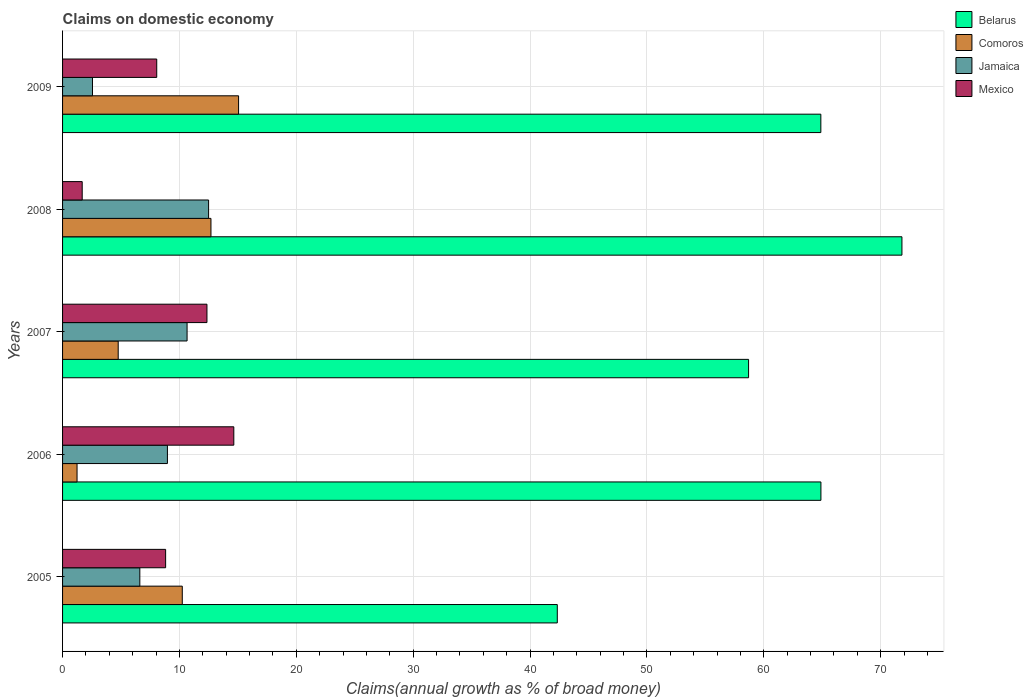How many different coloured bars are there?
Provide a short and direct response. 4. How many groups of bars are there?
Provide a short and direct response. 5. What is the label of the 2nd group of bars from the top?
Offer a terse response. 2008. What is the percentage of broad money claimed on domestic economy in Mexico in 2005?
Ensure brevity in your answer.  8.82. Across all years, what is the maximum percentage of broad money claimed on domestic economy in Comoros?
Provide a succinct answer. 15.06. Across all years, what is the minimum percentage of broad money claimed on domestic economy in Mexico?
Offer a terse response. 1.68. What is the total percentage of broad money claimed on domestic economy in Mexico in the graph?
Offer a very short reply. 45.56. What is the difference between the percentage of broad money claimed on domestic economy in Jamaica in 2008 and that in 2009?
Make the answer very short. 9.93. What is the difference between the percentage of broad money claimed on domestic economy in Belarus in 2005 and the percentage of broad money claimed on domestic economy in Jamaica in 2009?
Offer a very short reply. 39.77. What is the average percentage of broad money claimed on domestic economy in Belarus per year?
Offer a very short reply. 60.52. In the year 2008, what is the difference between the percentage of broad money claimed on domestic economy in Jamaica and percentage of broad money claimed on domestic economy in Comoros?
Make the answer very short. -0.2. What is the ratio of the percentage of broad money claimed on domestic economy in Jamaica in 2006 to that in 2008?
Provide a short and direct response. 0.72. What is the difference between the highest and the second highest percentage of broad money claimed on domestic economy in Mexico?
Keep it short and to the point. 2.3. What is the difference between the highest and the lowest percentage of broad money claimed on domestic economy in Comoros?
Ensure brevity in your answer.  13.82. What does the 2nd bar from the top in 2008 represents?
Your answer should be compact. Jamaica. Is it the case that in every year, the sum of the percentage of broad money claimed on domestic economy in Mexico and percentage of broad money claimed on domestic economy in Comoros is greater than the percentage of broad money claimed on domestic economy in Belarus?
Your response must be concise. No. How many bars are there?
Offer a terse response. 20. What is the difference between two consecutive major ticks on the X-axis?
Offer a very short reply. 10. Are the values on the major ticks of X-axis written in scientific E-notation?
Your response must be concise. No. Does the graph contain grids?
Your answer should be compact. Yes. What is the title of the graph?
Make the answer very short. Claims on domestic economy. Does "Bahrain" appear as one of the legend labels in the graph?
Ensure brevity in your answer.  No. What is the label or title of the X-axis?
Make the answer very short. Claims(annual growth as % of broad money). What is the Claims(annual growth as % of broad money) of Belarus in 2005?
Offer a very short reply. 42.33. What is the Claims(annual growth as % of broad money) of Comoros in 2005?
Give a very brief answer. 10.24. What is the Claims(annual growth as % of broad money) in Jamaica in 2005?
Make the answer very short. 6.61. What is the Claims(annual growth as % of broad money) in Mexico in 2005?
Your response must be concise. 8.82. What is the Claims(annual growth as % of broad money) of Belarus in 2006?
Offer a terse response. 64.89. What is the Claims(annual growth as % of broad money) in Comoros in 2006?
Offer a terse response. 1.24. What is the Claims(annual growth as % of broad money) of Jamaica in 2006?
Provide a short and direct response. 8.97. What is the Claims(annual growth as % of broad money) in Mexico in 2006?
Ensure brevity in your answer.  14.65. What is the Claims(annual growth as % of broad money) in Belarus in 2007?
Ensure brevity in your answer.  58.7. What is the Claims(annual growth as % of broad money) in Comoros in 2007?
Make the answer very short. 4.76. What is the Claims(annual growth as % of broad money) of Jamaica in 2007?
Ensure brevity in your answer.  10.65. What is the Claims(annual growth as % of broad money) in Mexico in 2007?
Your answer should be compact. 12.35. What is the Claims(annual growth as % of broad money) in Belarus in 2008?
Your answer should be compact. 71.82. What is the Claims(annual growth as % of broad money) of Comoros in 2008?
Your response must be concise. 12.7. What is the Claims(annual growth as % of broad money) of Jamaica in 2008?
Your response must be concise. 12.49. What is the Claims(annual growth as % of broad money) of Mexico in 2008?
Give a very brief answer. 1.68. What is the Claims(annual growth as % of broad money) in Belarus in 2009?
Your answer should be very brief. 64.88. What is the Claims(annual growth as % of broad money) of Comoros in 2009?
Ensure brevity in your answer.  15.06. What is the Claims(annual growth as % of broad money) of Jamaica in 2009?
Give a very brief answer. 2.56. What is the Claims(annual growth as % of broad money) in Mexico in 2009?
Your answer should be very brief. 8.06. Across all years, what is the maximum Claims(annual growth as % of broad money) in Belarus?
Keep it short and to the point. 71.82. Across all years, what is the maximum Claims(annual growth as % of broad money) in Comoros?
Your response must be concise. 15.06. Across all years, what is the maximum Claims(annual growth as % of broad money) in Jamaica?
Your response must be concise. 12.49. Across all years, what is the maximum Claims(annual growth as % of broad money) in Mexico?
Keep it short and to the point. 14.65. Across all years, what is the minimum Claims(annual growth as % of broad money) of Belarus?
Make the answer very short. 42.33. Across all years, what is the minimum Claims(annual growth as % of broad money) of Comoros?
Provide a short and direct response. 1.24. Across all years, what is the minimum Claims(annual growth as % of broad money) in Jamaica?
Make the answer very short. 2.56. Across all years, what is the minimum Claims(annual growth as % of broad money) of Mexico?
Your answer should be very brief. 1.68. What is the total Claims(annual growth as % of broad money) in Belarus in the graph?
Your answer should be compact. 302.62. What is the total Claims(annual growth as % of broad money) of Comoros in the graph?
Give a very brief answer. 44. What is the total Claims(annual growth as % of broad money) in Jamaica in the graph?
Ensure brevity in your answer.  41.29. What is the total Claims(annual growth as % of broad money) in Mexico in the graph?
Offer a very short reply. 45.56. What is the difference between the Claims(annual growth as % of broad money) of Belarus in 2005 and that in 2006?
Provide a short and direct response. -22.56. What is the difference between the Claims(annual growth as % of broad money) in Comoros in 2005 and that in 2006?
Ensure brevity in your answer.  9. What is the difference between the Claims(annual growth as % of broad money) of Jamaica in 2005 and that in 2006?
Offer a very short reply. -2.36. What is the difference between the Claims(annual growth as % of broad money) of Mexico in 2005 and that in 2006?
Provide a succinct answer. -5.83. What is the difference between the Claims(annual growth as % of broad money) in Belarus in 2005 and that in 2007?
Your answer should be very brief. -16.37. What is the difference between the Claims(annual growth as % of broad money) in Comoros in 2005 and that in 2007?
Your answer should be very brief. 5.48. What is the difference between the Claims(annual growth as % of broad money) in Jamaica in 2005 and that in 2007?
Provide a succinct answer. -4.04. What is the difference between the Claims(annual growth as % of broad money) in Mexico in 2005 and that in 2007?
Offer a terse response. -3.54. What is the difference between the Claims(annual growth as % of broad money) of Belarus in 2005 and that in 2008?
Keep it short and to the point. -29.49. What is the difference between the Claims(annual growth as % of broad money) in Comoros in 2005 and that in 2008?
Provide a succinct answer. -2.45. What is the difference between the Claims(annual growth as % of broad money) of Jamaica in 2005 and that in 2008?
Your answer should be compact. -5.88. What is the difference between the Claims(annual growth as % of broad money) of Mexico in 2005 and that in 2008?
Your answer should be very brief. 7.14. What is the difference between the Claims(annual growth as % of broad money) of Belarus in 2005 and that in 2009?
Your answer should be compact. -22.55. What is the difference between the Claims(annual growth as % of broad money) of Comoros in 2005 and that in 2009?
Your response must be concise. -4.82. What is the difference between the Claims(annual growth as % of broad money) in Jamaica in 2005 and that in 2009?
Provide a succinct answer. 4.05. What is the difference between the Claims(annual growth as % of broad money) of Mexico in 2005 and that in 2009?
Your answer should be very brief. 0.76. What is the difference between the Claims(annual growth as % of broad money) of Belarus in 2006 and that in 2007?
Provide a short and direct response. 6.19. What is the difference between the Claims(annual growth as % of broad money) of Comoros in 2006 and that in 2007?
Provide a succinct answer. -3.52. What is the difference between the Claims(annual growth as % of broad money) in Jamaica in 2006 and that in 2007?
Offer a very short reply. -1.68. What is the difference between the Claims(annual growth as % of broad money) in Mexico in 2006 and that in 2007?
Offer a terse response. 2.3. What is the difference between the Claims(annual growth as % of broad money) in Belarus in 2006 and that in 2008?
Your response must be concise. -6.93. What is the difference between the Claims(annual growth as % of broad money) in Comoros in 2006 and that in 2008?
Offer a very short reply. -11.46. What is the difference between the Claims(annual growth as % of broad money) in Jamaica in 2006 and that in 2008?
Ensure brevity in your answer.  -3.52. What is the difference between the Claims(annual growth as % of broad money) of Mexico in 2006 and that in 2008?
Make the answer very short. 12.97. What is the difference between the Claims(annual growth as % of broad money) of Belarus in 2006 and that in 2009?
Your answer should be very brief. 0.01. What is the difference between the Claims(annual growth as % of broad money) of Comoros in 2006 and that in 2009?
Offer a terse response. -13.82. What is the difference between the Claims(annual growth as % of broad money) of Jamaica in 2006 and that in 2009?
Give a very brief answer. 6.41. What is the difference between the Claims(annual growth as % of broad money) in Mexico in 2006 and that in 2009?
Provide a succinct answer. 6.59. What is the difference between the Claims(annual growth as % of broad money) of Belarus in 2007 and that in 2008?
Offer a terse response. -13.12. What is the difference between the Claims(annual growth as % of broad money) of Comoros in 2007 and that in 2008?
Give a very brief answer. -7.94. What is the difference between the Claims(annual growth as % of broad money) in Jamaica in 2007 and that in 2008?
Give a very brief answer. -1.84. What is the difference between the Claims(annual growth as % of broad money) in Mexico in 2007 and that in 2008?
Offer a terse response. 10.67. What is the difference between the Claims(annual growth as % of broad money) of Belarus in 2007 and that in 2009?
Make the answer very short. -6.18. What is the difference between the Claims(annual growth as % of broad money) of Comoros in 2007 and that in 2009?
Your response must be concise. -10.3. What is the difference between the Claims(annual growth as % of broad money) of Jamaica in 2007 and that in 2009?
Your answer should be compact. 8.09. What is the difference between the Claims(annual growth as % of broad money) in Mexico in 2007 and that in 2009?
Your answer should be very brief. 4.3. What is the difference between the Claims(annual growth as % of broad money) of Belarus in 2008 and that in 2009?
Your answer should be very brief. 6.94. What is the difference between the Claims(annual growth as % of broad money) in Comoros in 2008 and that in 2009?
Your answer should be very brief. -2.36. What is the difference between the Claims(annual growth as % of broad money) in Jamaica in 2008 and that in 2009?
Your answer should be very brief. 9.93. What is the difference between the Claims(annual growth as % of broad money) in Mexico in 2008 and that in 2009?
Keep it short and to the point. -6.38. What is the difference between the Claims(annual growth as % of broad money) in Belarus in 2005 and the Claims(annual growth as % of broad money) in Comoros in 2006?
Provide a succinct answer. 41.09. What is the difference between the Claims(annual growth as % of broad money) in Belarus in 2005 and the Claims(annual growth as % of broad money) in Jamaica in 2006?
Ensure brevity in your answer.  33.36. What is the difference between the Claims(annual growth as % of broad money) of Belarus in 2005 and the Claims(annual growth as % of broad money) of Mexico in 2006?
Your response must be concise. 27.68. What is the difference between the Claims(annual growth as % of broad money) in Comoros in 2005 and the Claims(annual growth as % of broad money) in Jamaica in 2006?
Offer a terse response. 1.27. What is the difference between the Claims(annual growth as % of broad money) in Comoros in 2005 and the Claims(annual growth as % of broad money) in Mexico in 2006?
Offer a very short reply. -4.41. What is the difference between the Claims(annual growth as % of broad money) in Jamaica in 2005 and the Claims(annual growth as % of broad money) in Mexico in 2006?
Your answer should be very brief. -8.04. What is the difference between the Claims(annual growth as % of broad money) in Belarus in 2005 and the Claims(annual growth as % of broad money) in Comoros in 2007?
Make the answer very short. 37.57. What is the difference between the Claims(annual growth as % of broad money) in Belarus in 2005 and the Claims(annual growth as % of broad money) in Jamaica in 2007?
Provide a short and direct response. 31.68. What is the difference between the Claims(annual growth as % of broad money) in Belarus in 2005 and the Claims(annual growth as % of broad money) in Mexico in 2007?
Make the answer very short. 29.98. What is the difference between the Claims(annual growth as % of broad money) in Comoros in 2005 and the Claims(annual growth as % of broad money) in Jamaica in 2007?
Make the answer very short. -0.41. What is the difference between the Claims(annual growth as % of broad money) in Comoros in 2005 and the Claims(annual growth as % of broad money) in Mexico in 2007?
Provide a succinct answer. -2.11. What is the difference between the Claims(annual growth as % of broad money) in Jamaica in 2005 and the Claims(annual growth as % of broad money) in Mexico in 2007?
Your answer should be compact. -5.74. What is the difference between the Claims(annual growth as % of broad money) in Belarus in 2005 and the Claims(annual growth as % of broad money) in Comoros in 2008?
Your answer should be compact. 29.64. What is the difference between the Claims(annual growth as % of broad money) of Belarus in 2005 and the Claims(annual growth as % of broad money) of Jamaica in 2008?
Make the answer very short. 29.84. What is the difference between the Claims(annual growth as % of broad money) of Belarus in 2005 and the Claims(annual growth as % of broad money) of Mexico in 2008?
Ensure brevity in your answer.  40.65. What is the difference between the Claims(annual growth as % of broad money) in Comoros in 2005 and the Claims(annual growth as % of broad money) in Jamaica in 2008?
Ensure brevity in your answer.  -2.25. What is the difference between the Claims(annual growth as % of broad money) in Comoros in 2005 and the Claims(annual growth as % of broad money) in Mexico in 2008?
Your answer should be very brief. 8.56. What is the difference between the Claims(annual growth as % of broad money) of Jamaica in 2005 and the Claims(annual growth as % of broad money) of Mexico in 2008?
Keep it short and to the point. 4.93. What is the difference between the Claims(annual growth as % of broad money) in Belarus in 2005 and the Claims(annual growth as % of broad money) in Comoros in 2009?
Make the answer very short. 27.27. What is the difference between the Claims(annual growth as % of broad money) in Belarus in 2005 and the Claims(annual growth as % of broad money) in Jamaica in 2009?
Your answer should be very brief. 39.77. What is the difference between the Claims(annual growth as % of broad money) of Belarus in 2005 and the Claims(annual growth as % of broad money) of Mexico in 2009?
Keep it short and to the point. 34.27. What is the difference between the Claims(annual growth as % of broad money) of Comoros in 2005 and the Claims(annual growth as % of broad money) of Jamaica in 2009?
Give a very brief answer. 7.68. What is the difference between the Claims(annual growth as % of broad money) of Comoros in 2005 and the Claims(annual growth as % of broad money) of Mexico in 2009?
Ensure brevity in your answer.  2.19. What is the difference between the Claims(annual growth as % of broad money) of Jamaica in 2005 and the Claims(annual growth as % of broad money) of Mexico in 2009?
Keep it short and to the point. -1.45. What is the difference between the Claims(annual growth as % of broad money) of Belarus in 2006 and the Claims(annual growth as % of broad money) of Comoros in 2007?
Ensure brevity in your answer.  60.13. What is the difference between the Claims(annual growth as % of broad money) of Belarus in 2006 and the Claims(annual growth as % of broad money) of Jamaica in 2007?
Give a very brief answer. 54.24. What is the difference between the Claims(annual growth as % of broad money) of Belarus in 2006 and the Claims(annual growth as % of broad money) of Mexico in 2007?
Provide a short and direct response. 52.54. What is the difference between the Claims(annual growth as % of broad money) of Comoros in 2006 and the Claims(annual growth as % of broad money) of Jamaica in 2007?
Ensure brevity in your answer.  -9.41. What is the difference between the Claims(annual growth as % of broad money) in Comoros in 2006 and the Claims(annual growth as % of broad money) in Mexico in 2007?
Offer a terse response. -11.12. What is the difference between the Claims(annual growth as % of broad money) of Jamaica in 2006 and the Claims(annual growth as % of broad money) of Mexico in 2007?
Give a very brief answer. -3.38. What is the difference between the Claims(annual growth as % of broad money) in Belarus in 2006 and the Claims(annual growth as % of broad money) in Comoros in 2008?
Ensure brevity in your answer.  52.19. What is the difference between the Claims(annual growth as % of broad money) in Belarus in 2006 and the Claims(annual growth as % of broad money) in Jamaica in 2008?
Provide a short and direct response. 52.39. What is the difference between the Claims(annual growth as % of broad money) of Belarus in 2006 and the Claims(annual growth as % of broad money) of Mexico in 2008?
Make the answer very short. 63.21. What is the difference between the Claims(annual growth as % of broad money) of Comoros in 2006 and the Claims(annual growth as % of broad money) of Jamaica in 2008?
Ensure brevity in your answer.  -11.26. What is the difference between the Claims(annual growth as % of broad money) in Comoros in 2006 and the Claims(annual growth as % of broad money) in Mexico in 2008?
Make the answer very short. -0.44. What is the difference between the Claims(annual growth as % of broad money) in Jamaica in 2006 and the Claims(annual growth as % of broad money) in Mexico in 2008?
Provide a succinct answer. 7.29. What is the difference between the Claims(annual growth as % of broad money) of Belarus in 2006 and the Claims(annual growth as % of broad money) of Comoros in 2009?
Provide a succinct answer. 49.83. What is the difference between the Claims(annual growth as % of broad money) of Belarus in 2006 and the Claims(annual growth as % of broad money) of Jamaica in 2009?
Ensure brevity in your answer.  62.33. What is the difference between the Claims(annual growth as % of broad money) of Belarus in 2006 and the Claims(annual growth as % of broad money) of Mexico in 2009?
Provide a succinct answer. 56.83. What is the difference between the Claims(annual growth as % of broad money) of Comoros in 2006 and the Claims(annual growth as % of broad money) of Jamaica in 2009?
Your answer should be compact. -1.32. What is the difference between the Claims(annual growth as % of broad money) in Comoros in 2006 and the Claims(annual growth as % of broad money) in Mexico in 2009?
Your answer should be compact. -6.82. What is the difference between the Claims(annual growth as % of broad money) in Jamaica in 2006 and the Claims(annual growth as % of broad money) in Mexico in 2009?
Offer a terse response. 0.92. What is the difference between the Claims(annual growth as % of broad money) of Belarus in 2007 and the Claims(annual growth as % of broad money) of Comoros in 2008?
Your answer should be compact. 46. What is the difference between the Claims(annual growth as % of broad money) in Belarus in 2007 and the Claims(annual growth as % of broad money) in Jamaica in 2008?
Provide a short and direct response. 46.2. What is the difference between the Claims(annual growth as % of broad money) in Belarus in 2007 and the Claims(annual growth as % of broad money) in Mexico in 2008?
Ensure brevity in your answer.  57.02. What is the difference between the Claims(annual growth as % of broad money) of Comoros in 2007 and the Claims(annual growth as % of broad money) of Jamaica in 2008?
Offer a very short reply. -7.73. What is the difference between the Claims(annual growth as % of broad money) of Comoros in 2007 and the Claims(annual growth as % of broad money) of Mexico in 2008?
Your answer should be compact. 3.08. What is the difference between the Claims(annual growth as % of broad money) in Jamaica in 2007 and the Claims(annual growth as % of broad money) in Mexico in 2008?
Offer a very short reply. 8.97. What is the difference between the Claims(annual growth as % of broad money) of Belarus in 2007 and the Claims(annual growth as % of broad money) of Comoros in 2009?
Provide a short and direct response. 43.64. What is the difference between the Claims(annual growth as % of broad money) in Belarus in 2007 and the Claims(annual growth as % of broad money) in Jamaica in 2009?
Offer a terse response. 56.14. What is the difference between the Claims(annual growth as % of broad money) of Belarus in 2007 and the Claims(annual growth as % of broad money) of Mexico in 2009?
Make the answer very short. 50.64. What is the difference between the Claims(annual growth as % of broad money) of Comoros in 2007 and the Claims(annual growth as % of broad money) of Jamaica in 2009?
Make the answer very short. 2.2. What is the difference between the Claims(annual growth as % of broad money) in Comoros in 2007 and the Claims(annual growth as % of broad money) in Mexico in 2009?
Offer a terse response. -3.3. What is the difference between the Claims(annual growth as % of broad money) of Jamaica in 2007 and the Claims(annual growth as % of broad money) of Mexico in 2009?
Keep it short and to the point. 2.6. What is the difference between the Claims(annual growth as % of broad money) of Belarus in 2008 and the Claims(annual growth as % of broad money) of Comoros in 2009?
Give a very brief answer. 56.76. What is the difference between the Claims(annual growth as % of broad money) in Belarus in 2008 and the Claims(annual growth as % of broad money) in Jamaica in 2009?
Provide a succinct answer. 69.26. What is the difference between the Claims(annual growth as % of broad money) in Belarus in 2008 and the Claims(annual growth as % of broad money) in Mexico in 2009?
Provide a short and direct response. 63.76. What is the difference between the Claims(annual growth as % of broad money) in Comoros in 2008 and the Claims(annual growth as % of broad money) in Jamaica in 2009?
Offer a very short reply. 10.14. What is the difference between the Claims(annual growth as % of broad money) in Comoros in 2008 and the Claims(annual growth as % of broad money) in Mexico in 2009?
Your answer should be compact. 4.64. What is the difference between the Claims(annual growth as % of broad money) of Jamaica in 2008 and the Claims(annual growth as % of broad money) of Mexico in 2009?
Offer a terse response. 4.44. What is the average Claims(annual growth as % of broad money) in Belarus per year?
Keep it short and to the point. 60.52. What is the average Claims(annual growth as % of broad money) of Comoros per year?
Provide a succinct answer. 8.8. What is the average Claims(annual growth as % of broad money) in Jamaica per year?
Offer a very short reply. 8.26. What is the average Claims(annual growth as % of broad money) in Mexico per year?
Keep it short and to the point. 9.11. In the year 2005, what is the difference between the Claims(annual growth as % of broad money) of Belarus and Claims(annual growth as % of broad money) of Comoros?
Give a very brief answer. 32.09. In the year 2005, what is the difference between the Claims(annual growth as % of broad money) in Belarus and Claims(annual growth as % of broad money) in Jamaica?
Make the answer very short. 35.72. In the year 2005, what is the difference between the Claims(annual growth as % of broad money) in Belarus and Claims(annual growth as % of broad money) in Mexico?
Provide a short and direct response. 33.51. In the year 2005, what is the difference between the Claims(annual growth as % of broad money) of Comoros and Claims(annual growth as % of broad money) of Jamaica?
Your answer should be very brief. 3.63. In the year 2005, what is the difference between the Claims(annual growth as % of broad money) in Comoros and Claims(annual growth as % of broad money) in Mexico?
Provide a succinct answer. 1.43. In the year 2005, what is the difference between the Claims(annual growth as % of broad money) of Jamaica and Claims(annual growth as % of broad money) of Mexico?
Provide a short and direct response. -2.21. In the year 2006, what is the difference between the Claims(annual growth as % of broad money) in Belarus and Claims(annual growth as % of broad money) in Comoros?
Make the answer very short. 63.65. In the year 2006, what is the difference between the Claims(annual growth as % of broad money) in Belarus and Claims(annual growth as % of broad money) in Jamaica?
Offer a very short reply. 55.92. In the year 2006, what is the difference between the Claims(annual growth as % of broad money) in Belarus and Claims(annual growth as % of broad money) in Mexico?
Keep it short and to the point. 50.24. In the year 2006, what is the difference between the Claims(annual growth as % of broad money) in Comoros and Claims(annual growth as % of broad money) in Jamaica?
Ensure brevity in your answer.  -7.73. In the year 2006, what is the difference between the Claims(annual growth as % of broad money) of Comoros and Claims(annual growth as % of broad money) of Mexico?
Offer a terse response. -13.41. In the year 2006, what is the difference between the Claims(annual growth as % of broad money) of Jamaica and Claims(annual growth as % of broad money) of Mexico?
Provide a short and direct response. -5.68. In the year 2007, what is the difference between the Claims(annual growth as % of broad money) in Belarus and Claims(annual growth as % of broad money) in Comoros?
Make the answer very short. 53.94. In the year 2007, what is the difference between the Claims(annual growth as % of broad money) in Belarus and Claims(annual growth as % of broad money) in Jamaica?
Give a very brief answer. 48.04. In the year 2007, what is the difference between the Claims(annual growth as % of broad money) in Belarus and Claims(annual growth as % of broad money) in Mexico?
Your answer should be compact. 46.34. In the year 2007, what is the difference between the Claims(annual growth as % of broad money) of Comoros and Claims(annual growth as % of broad money) of Jamaica?
Give a very brief answer. -5.89. In the year 2007, what is the difference between the Claims(annual growth as % of broad money) of Comoros and Claims(annual growth as % of broad money) of Mexico?
Keep it short and to the point. -7.59. In the year 2007, what is the difference between the Claims(annual growth as % of broad money) in Jamaica and Claims(annual growth as % of broad money) in Mexico?
Provide a succinct answer. -1.7. In the year 2008, what is the difference between the Claims(annual growth as % of broad money) in Belarus and Claims(annual growth as % of broad money) in Comoros?
Give a very brief answer. 59.13. In the year 2008, what is the difference between the Claims(annual growth as % of broad money) in Belarus and Claims(annual growth as % of broad money) in Jamaica?
Keep it short and to the point. 59.33. In the year 2008, what is the difference between the Claims(annual growth as % of broad money) of Belarus and Claims(annual growth as % of broad money) of Mexico?
Make the answer very short. 70.14. In the year 2008, what is the difference between the Claims(annual growth as % of broad money) in Comoros and Claims(annual growth as % of broad money) in Jamaica?
Offer a very short reply. 0.2. In the year 2008, what is the difference between the Claims(annual growth as % of broad money) of Comoros and Claims(annual growth as % of broad money) of Mexico?
Your answer should be very brief. 11.02. In the year 2008, what is the difference between the Claims(annual growth as % of broad money) in Jamaica and Claims(annual growth as % of broad money) in Mexico?
Ensure brevity in your answer.  10.81. In the year 2009, what is the difference between the Claims(annual growth as % of broad money) in Belarus and Claims(annual growth as % of broad money) in Comoros?
Offer a terse response. 49.82. In the year 2009, what is the difference between the Claims(annual growth as % of broad money) of Belarus and Claims(annual growth as % of broad money) of Jamaica?
Your response must be concise. 62.32. In the year 2009, what is the difference between the Claims(annual growth as % of broad money) of Belarus and Claims(annual growth as % of broad money) of Mexico?
Your response must be concise. 56.82. In the year 2009, what is the difference between the Claims(annual growth as % of broad money) of Comoros and Claims(annual growth as % of broad money) of Jamaica?
Your answer should be compact. 12.5. In the year 2009, what is the difference between the Claims(annual growth as % of broad money) of Comoros and Claims(annual growth as % of broad money) of Mexico?
Your answer should be compact. 7. In the year 2009, what is the difference between the Claims(annual growth as % of broad money) in Jamaica and Claims(annual growth as % of broad money) in Mexico?
Keep it short and to the point. -5.5. What is the ratio of the Claims(annual growth as % of broad money) of Belarus in 2005 to that in 2006?
Your answer should be very brief. 0.65. What is the ratio of the Claims(annual growth as % of broad money) of Comoros in 2005 to that in 2006?
Your answer should be compact. 8.27. What is the ratio of the Claims(annual growth as % of broad money) of Jamaica in 2005 to that in 2006?
Provide a succinct answer. 0.74. What is the ratio of the Claims(annual growth as % of broad money) of Mexico in 2005 to that in 2006?
Offer a very short reply. 0.6. What is the ratio of the Claims(annual growth as % of broad money) in Belarus in 2005 to that in 2007?
Your answer should be compact. 0.72. What is the ratio of the Claims(annual growth as % of broad money) in Comoros in 2005 to that in 2007?
Keep it short and to the point. 2.15. What is the ratio of the Claims(annual growth as % of broad money) in Jamaica in 2005 to that in 2007?
Offer a terse response. 0.62. What is the ratio of the Claims(annual growth as % of broad money) in Mexico in 2005 to that in 2007?
Your answer should be very brief. 0.71. What is the ratio of the Claims(annual growth as % of broad money) of Belarus in 2005 to that in 2008?
Your response must be concise. 0.59. What is the ratio of the Claims(annual growth as % of broad money) in Comoros in 2005 to that in 2008?
Offer a terse response. 0.81. What is the ratio of the Claims(annual growth as % of broad money) in Jamaica in 2005 to that in 2008?
Your response must be concise. 0.53. What is the ratio of the Claims(annual growth as % of broad money) of Mexico in 2005 to that in 2008?
Offer a very short reply. 5.25. What is the ratio of the Claims(annual growth as % of broad money) in Belarus in 2005 to that in 2009?
Offer a terse response. 0.65. What is the ratio of the Claims(annual growth as % of broad money) in Comoros in 2005 to that in 2009?
Your response must be concise. 0.68. What is the ratio of the Claims(annual growth as % of broad money) of Jamaica in 2005 to that in 2009?
Provide a succinct answer. 2.58. What is the ratio of the Claims(annual growth as % of broad money) of Mexico in 2005 to that in 2009?
Give a very brief answer. 1.09. What is the ratio of the Claims(annual growth as % of broad money) in Belarus in 2006 to that in 2007?
Offer a very short reply. 1.11. What is the ratio of the Claims(annual growth as % of broad money) in Comoros in 2006 to that in 2007?
Your answer should be compact. 0.26. What is the ratio of the Claims(annual growth as % of broad money) of Jamaica in 2006 to that in 2007?
Your response must be concise. 0.84. What is the ratio of the Claims(annual growth as % of broad money) of Mexico in 2006 to that in 2007?
Keep it short and to the point. 1.19. What is the ratio of the Claims(annual growth as % of broad money) of Belarus in 2006 to that in 2008?
Your answer should be very brief. 0.9. What is the ratio of the Claims(annual growth as % of broad money) in Comoros in 2006 to that in 2008?
Give a very brief answer. 0.1. What is the ratio of the Claims(annual growth as % of broad money) of Jamaica in 2006 to that in 2008?
Keep it short and to the point. 0.72. What is the ratio of the Claims(annual growth as % of broad money) in Mexico in 2006 to that in 2008?
Your answer should be very brief. 8.72. What is the ratio of the Claims(annual growth as % of broad money) in Comoros in 2006 to that in 2009?
Your response must be concise. 0.08. What is the ratio of the Claims(annual growth as % of broad money) of Jamaica in 2006 to that in 2009?
Keep it short and to the point. 3.51. What is the ratio of the Claims(annual growth as % of broad money) of Mexico in 2006 to that in 2009?
Offer a terse response. 1.82. What is the ratio of the Claims(annual growth as % of broad money) in Belarus in 2007 to that in 2008?
Provide a short and direct response. 0.82. What is the ratio of the Claims(annual growth as % of broad money) of Comoros in 2007 to that in 2008?
Your response must be concise. 0.37. What is the ratio of the Claims(annual growth as % of broad money) in Jamaica in 2007 to that in 2008?
Provide a short and direct response. 0.85. What is the ratio of the Claims(annual growth as % of broad money) in Mexico in 2007 to that in 2008?
Your answer should be very brief. 7.35. What is the ratio of the Claims(annual growth as % of broad money) of Belarus in 2007 to that in 2009?
Provide a short and direct response. 0.9. What is the ratio of the Claims(annual growth as % of broad money) in Comoros in 2007 to that in 2009?
Your answer should be compact. 0.32. What is the ratio of the Claims(annual growth as % of broad money) of Jamaica in 2007 to that in 2009?
Your answer should be compact. 4.16. What is the ratio of the Claims(annual growth as % of broad money) of Mexico in 2007 to that in 2009?
Offer a terse response. 1.53. What is the ratio of the Claims(annual growth as % of broad money) in Belarus in 2008 to that in 2009?
Give a very brief answer. 1.11. What is the ratio of the Claims(annual growth as % of broad money) in Comoros in 2008 to that in 2009?
Your answer should be compact. 0.84. What is the ratio of the Claims(annual growth as % of broad money) of Jamaica in 2008 to that in 2009?
Provide a short and direct response. 4.88. What is the ratio of the Claims(annual growth as % of broad money) of Mexico in 2008 to that in 2009?
Offer a terse response. 0.21. What is the difference between the highest and the second highest Claims(annual growth as % of broad money) in Belarus?
Ensure brevity in your answer.  6.93. What is the difference between the highest and the second highest Claims(annual growth as % of broad money) of Comoros?
Provide a short and direct response. 2.36. What is the difference between the highest and the second highest Claims(annual growth as % of broad money) in Jamaica?
Offer a very short reply. 1.84. What is the difference between the highest and the second highest Claims(annual growth as % of broad money) of Mexico?
Your answer should be compact. 2.3. What is the difference between the highest and the lowest Claims(annual growth as % of broad money) in Belarus?
Your response must be concise. 29.49. What is the difference between the highest and the lowest Claims(annual growth as % of broad money) in Comoros?
Provide a succinct answer. 13.82. What is the difference between the highest and the lowest Claims(annual growth as % of broad money) of Jamaica?
Keep it short and to the point. 9.93. What is the difference between the highest and the lowest Claims(annual growth as % of broad money) in Mexico?
Ensure brevity in your answer.  12.97. 